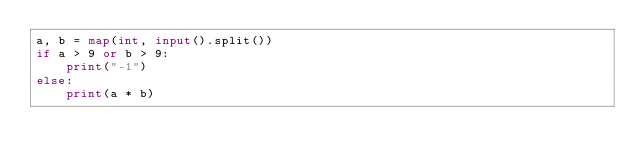Convert code to text. <code><loc_0><loc_0><loc_500><loc_500><_Python_>a, b = map(int, input().split())
if a > 9 or b > 9:
    print("-1")
else:
    print(a * b)
</code> 